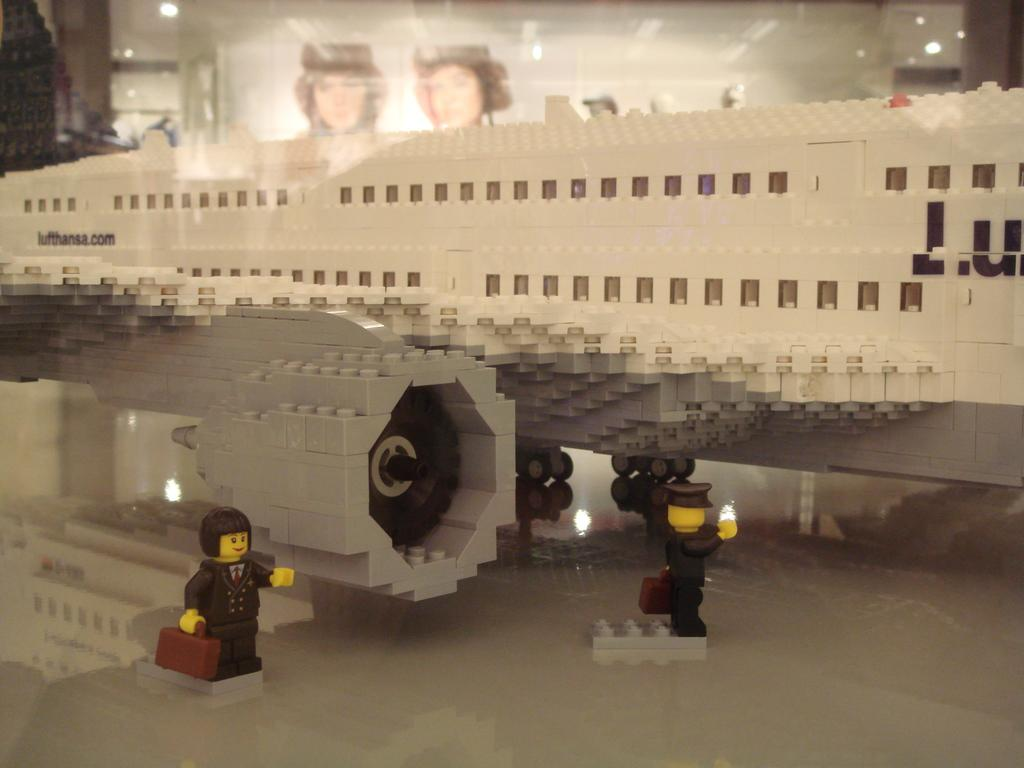What is the main subject in the center of the image? There is an aeroplane made with legos in the center of the image. Are there any other legos structures visible in the image? Yes, there are two persons made with legos at the bottom of the image. What can be seen in the background of the image? There is a wall in the background of the image. What is the price of the eggs in the image? There are no eggs present in the image, so it is not possible to determine their price. 